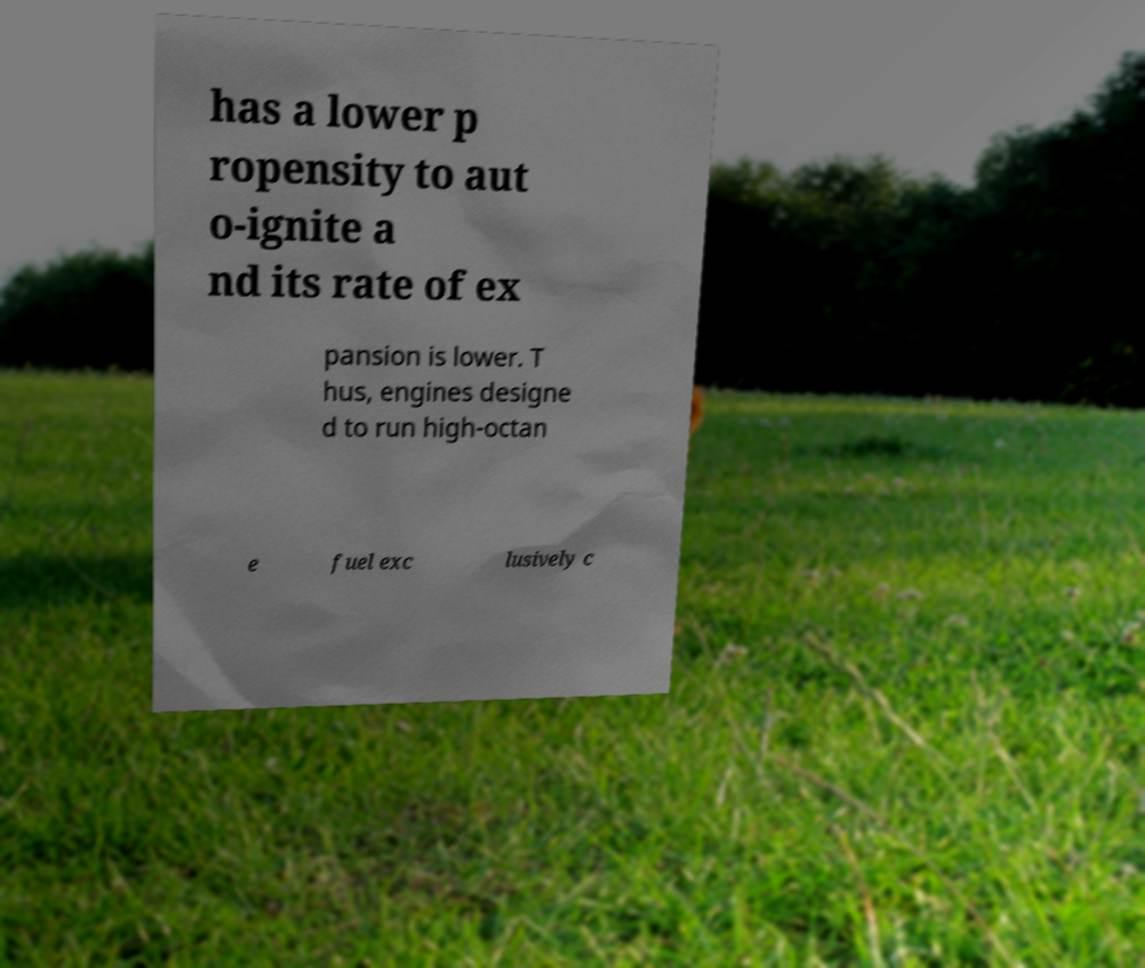Can you accurately transcribe the text from the provided image for me? has a lower p ropensity to aut o-ignite a nd its rate of ex pansion is lower. T hus, engines designe d to run high-octan e fuel exc lusively c 